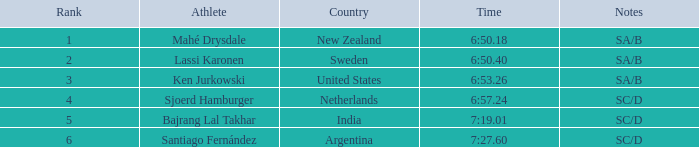What is the supreme standing for the team that completed a time of 6:5 2.0. 